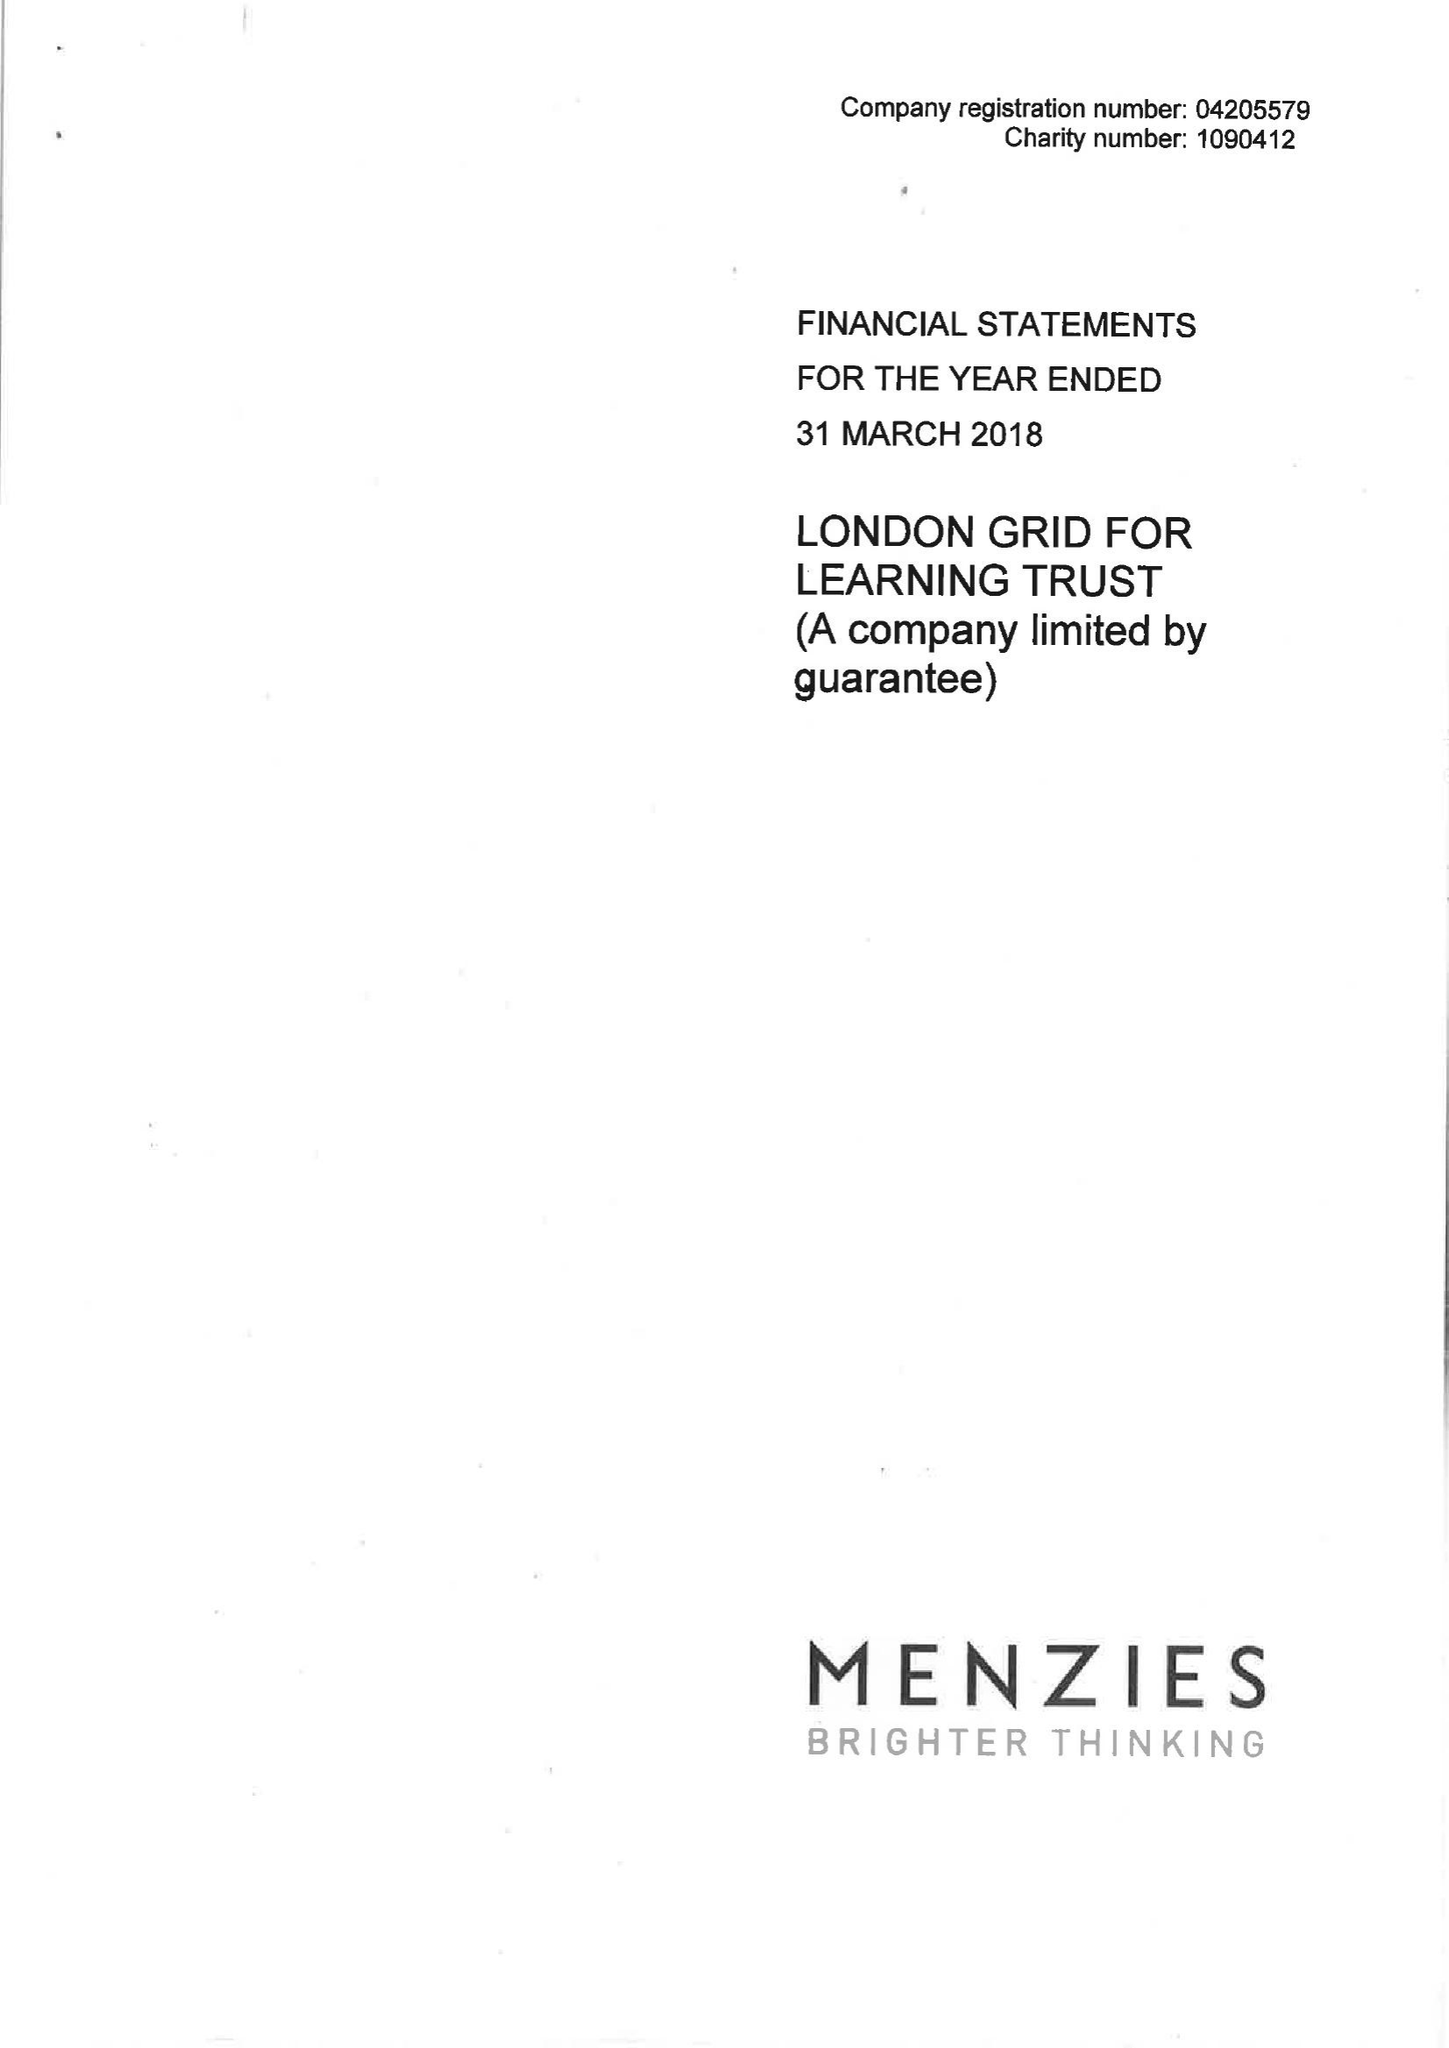What is the value for the charity_name?
Answer the question using a single word or phrase. London Grid For Learning Trust 